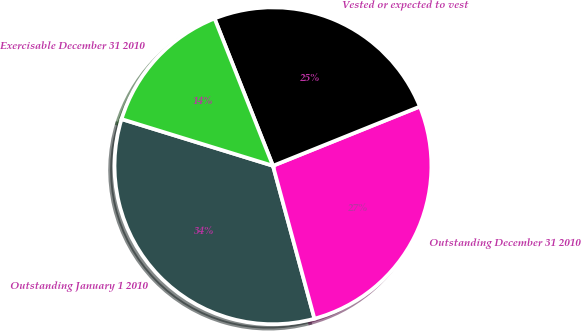<chart> <loc_0><loc_0><loc_500><loc_500><pie_chart><fcel>Outstanding January 1 2010<fcel>Outstanding December 31 2010<fcel>Vested or expected to vest<fcel>Exercisable December 31 2010<nl><fcel>33.98%<fcel>26.88%<fcel>24.91%<fcel>14.23%<nl></chart> 